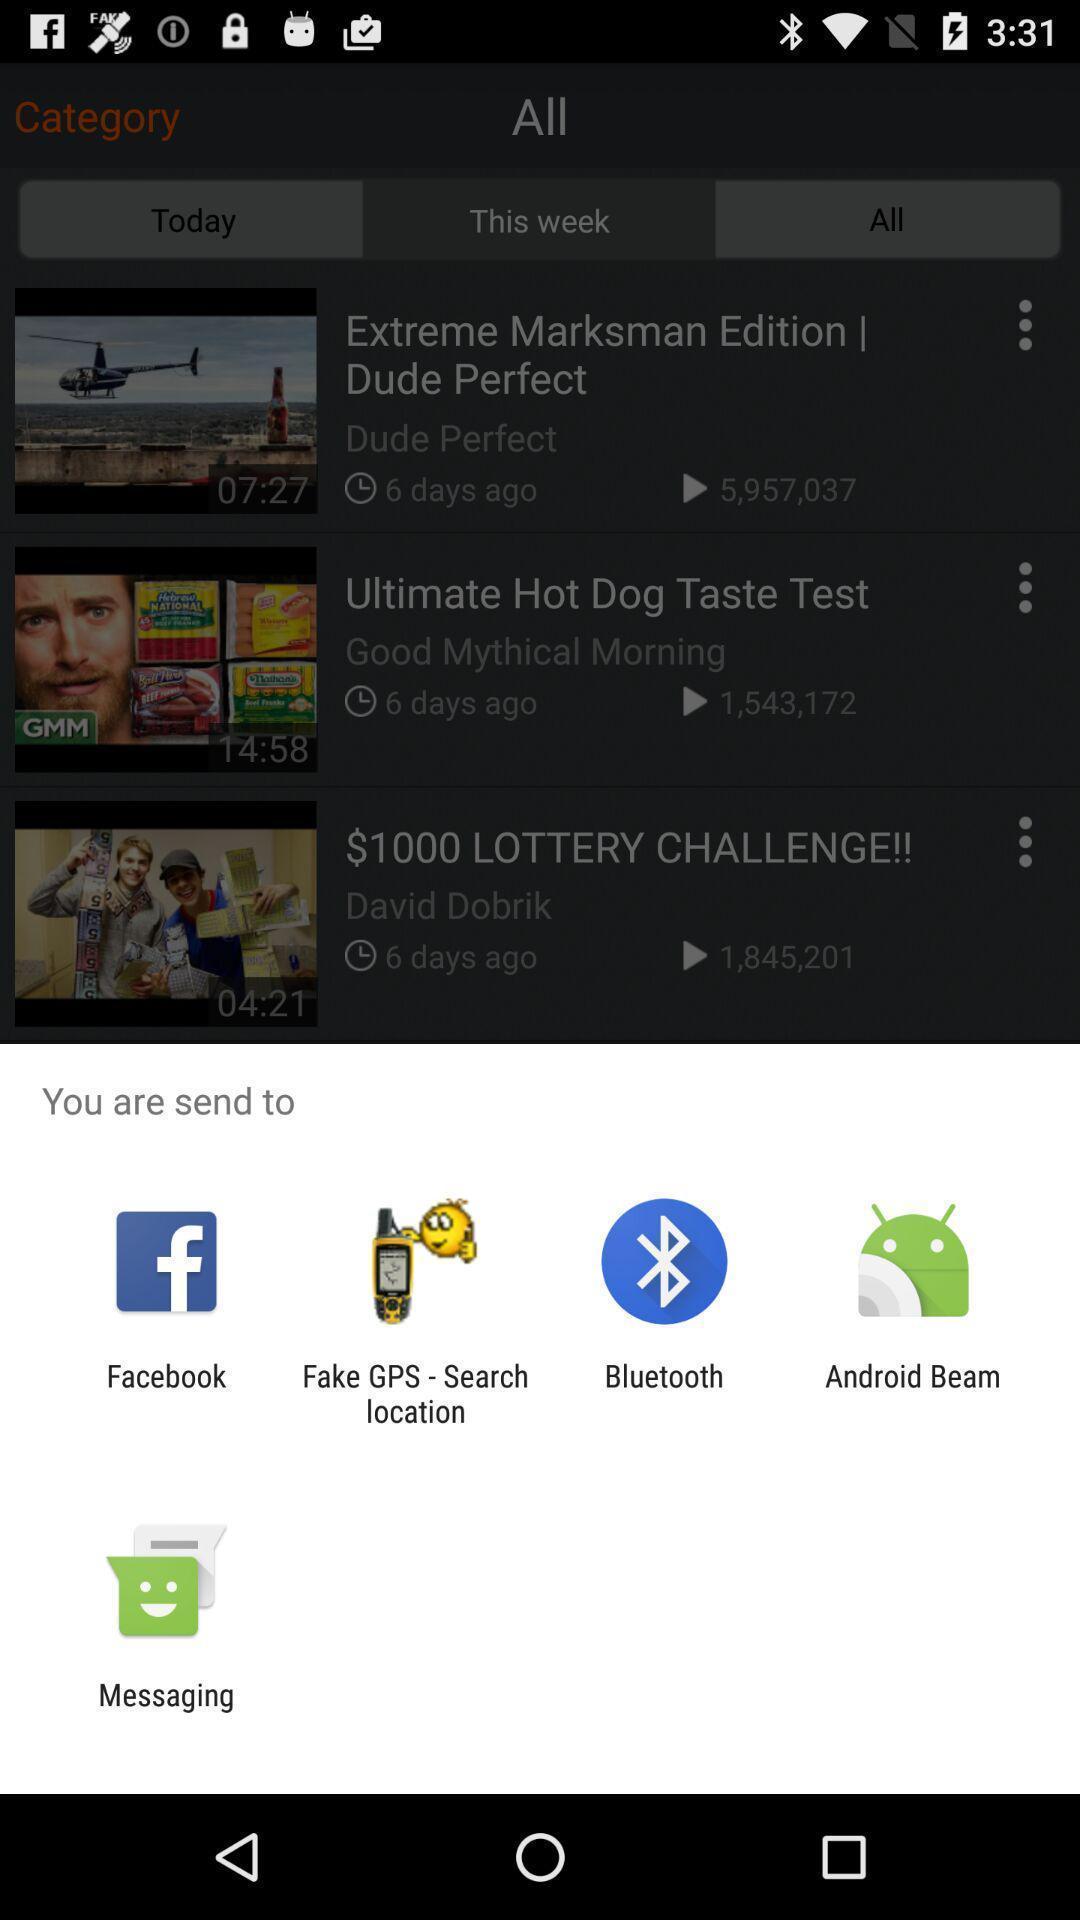What details can you identify in this image? Popup showing different options to share the file. 